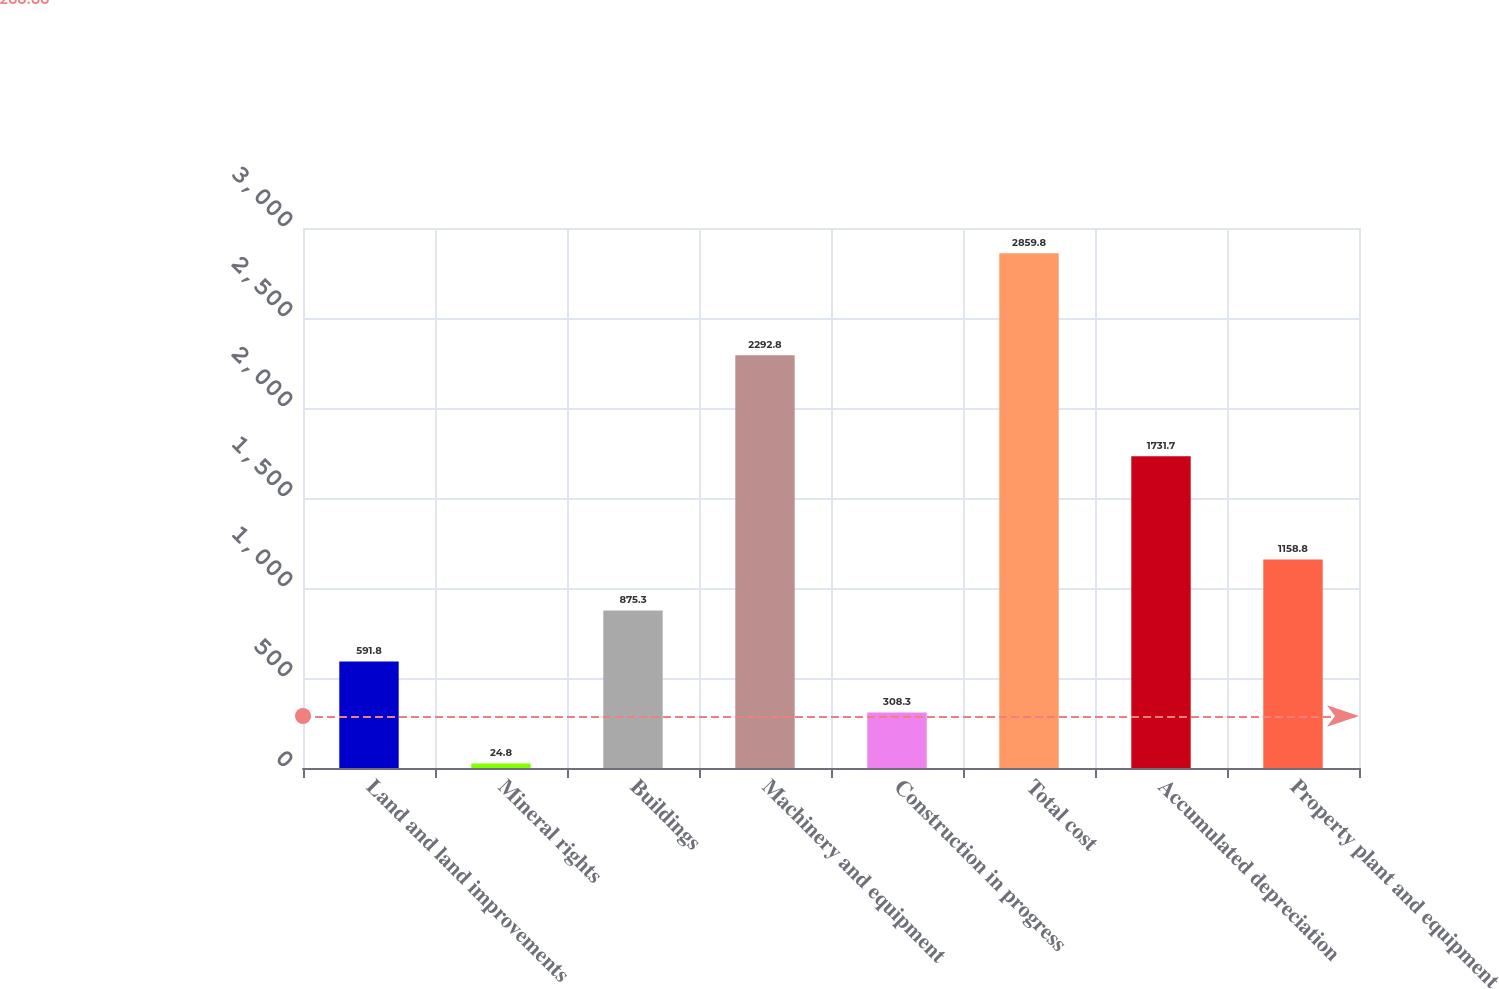<chart> <loc_0><loc_0><loc_500><loc_500><bar_chart><fcel>Land and land improvements<fcel>Mineral rights<fcel>Buildings<fcel>Machinery and equipment<fcel>Construction in progress<fcel>Total cost<fcel>Accumulated depreciation<fcel>Property plant and equipment<nl><fcel>591.8<fcel>24.8<fcel>875.3<fcel>2292.8<fcel>308.3<fcel>2859.8<fcel>1731.7<fcel>1158.8<nl></chart> 